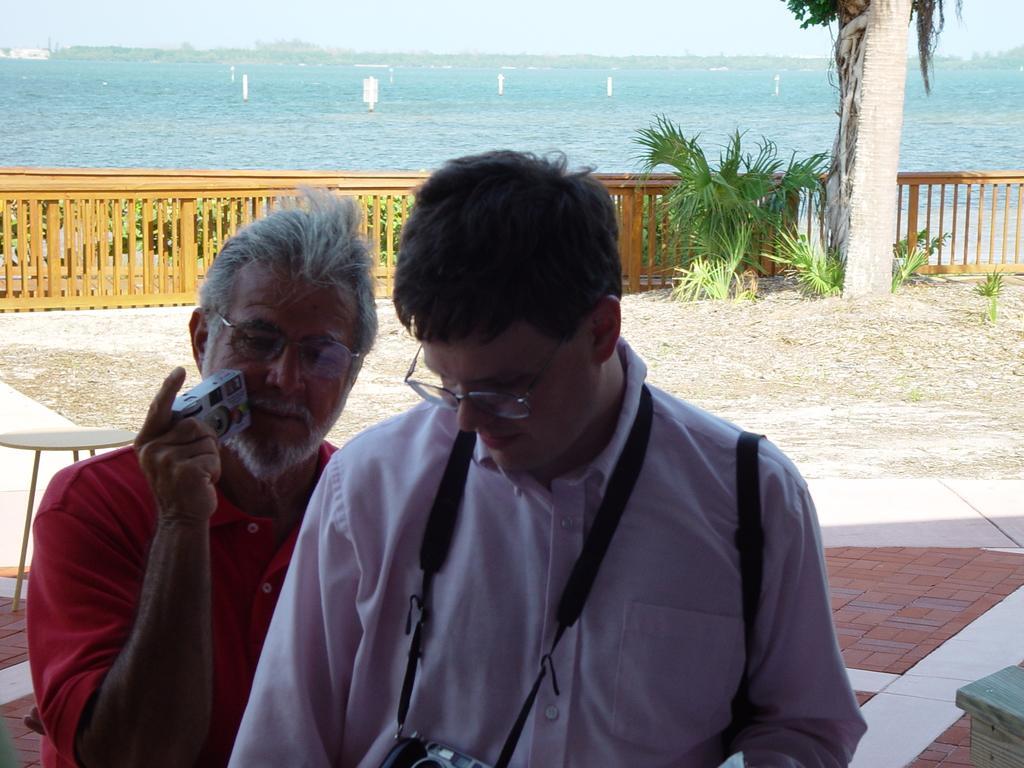How would you summarize this image in a sentence or two? in this image there are two persons standing at bottom of this image. The right side person is wearing spects and white color shirt and holding a camera and the left side person is wearing a red color dress and holding a camera. There is a table at left side of this image. there are some plants at right side of this image and there is a sea at top of this image. 